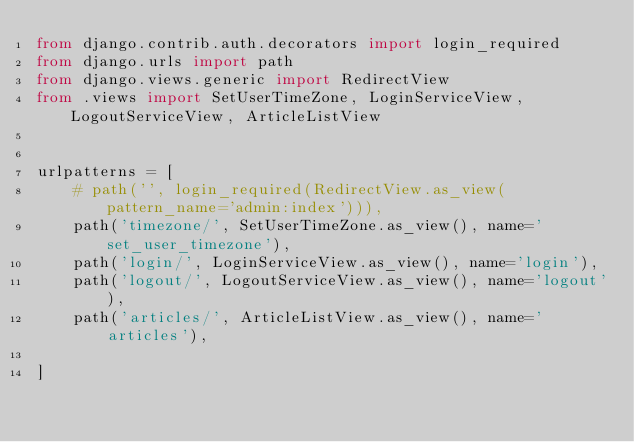Convert code to text. <code><loc_0><loc_0><loc_500><loc_500><_Python_>from django.contrib.auth.decorators import login_required
from django.urls import path
from django.views.generic import RedirectView
from .views import SetUserTimeZone, LoginServiceView, LogoutServiceView, ArticleListView


urlpatterns = [
    # path('', login_required(RedirectView.as_view(pattern_name='admin:index'))),
    path('timezone/', SetUserTimeZone.as_view(), name='set_user_timezone'),
    path('login/', LoginServiceView.as_view(), name='login'),
    path('logout/', LogoutServiceView.as_view(), name='logout'),
    path('articles/', ArticleListView.as_view(), name='articles'),

]
</code> 